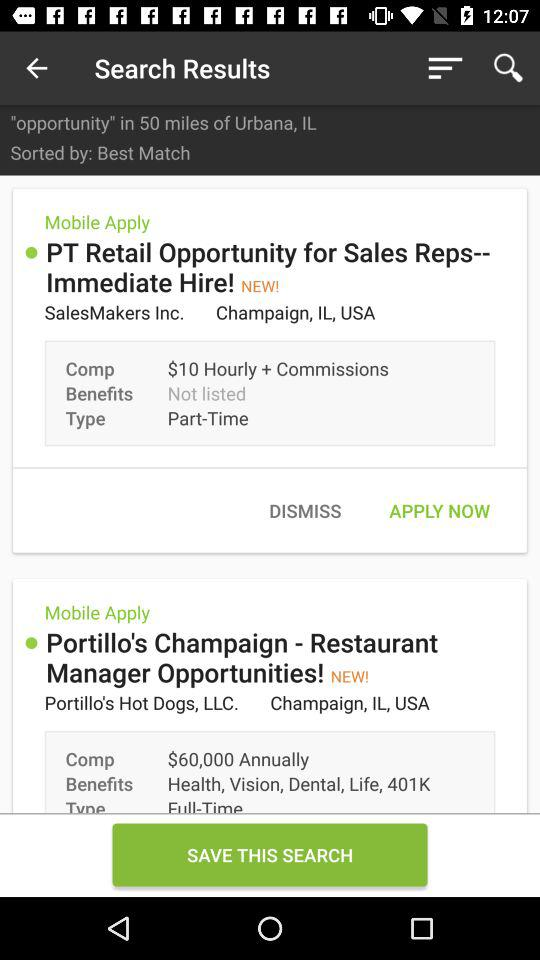What is the location of "SalesMakers Inc."? The location of "SalesMakers Inc." is Champaign, IL, USA. 